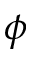Convert formula to latex. <formula><loc_0><loc_0><loc_500><loc_500>\phi</formula> 